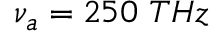Convert formula to latex. <formula><loc_0><loc_0><loc_500><loc_500>\nu _ { a } = 2 5 0 T H z</formula> 